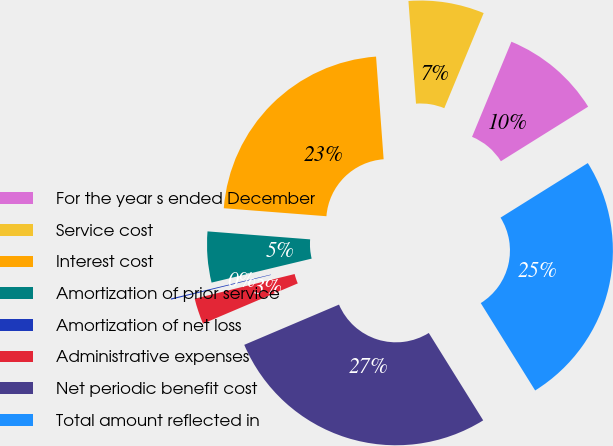<chart> <loc_0><loc_0><loc_500><loc_500><pie_chart><fcel>For the year s ended December<fcel>Service cost<fcel>Interest cost<fcel>Amortization of prior service<fcel>Amortization of net loss<fcel>Administrative expenses<fcel>Net periodic benefit cost<fcel>Total amount reflected in<nl><fcel>9.86%<fcel>7.42%<fcel>22.59%<fcel>4.98%<fcel>0.11%<fcel>2.54%<fcel>27.47%<fcel>25.03%<nl></chart> 